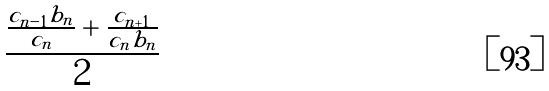Convert formula to latex. <formula><loc_0><loc_0><loc_500><loc_500>\frac { \frac { c _ { n - 1 } b _ { n } } { c _ { n } } + \frac { c _ { n + 1 } } { c _ { n } b _ { n } } } { 2 }</formula> 